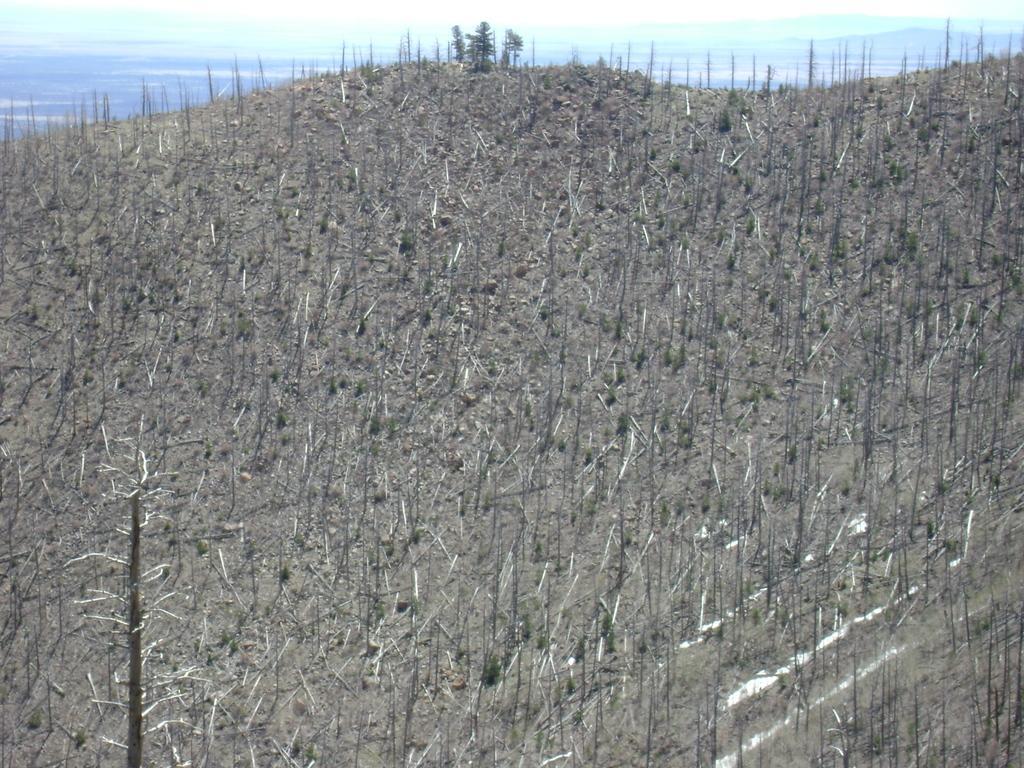Can you describe this image briefly? In this image we can see dried plants and trees. In the background of the image there are mountains and sky. 